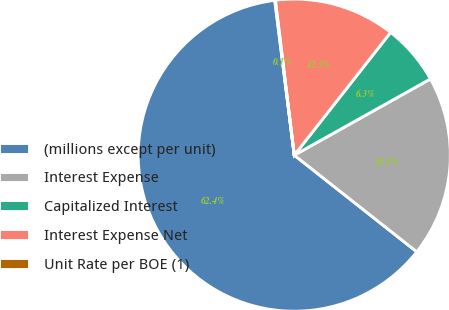Convert chart to OTSL. <chart><loc_0><loc_0><loc_500><loc_500><pie_chart><fcel>(millions except per unit)<fcel>Interest Expense<fcel>Capitalized Interest<fcel>Interest Expense Net<fcel>Unit Rate per BOE (1)<nl><fcel>62.37%<fcel>18.75%<fcel>6.29%<fcel>12.52%<fcel>0.06%<nl></chart> 